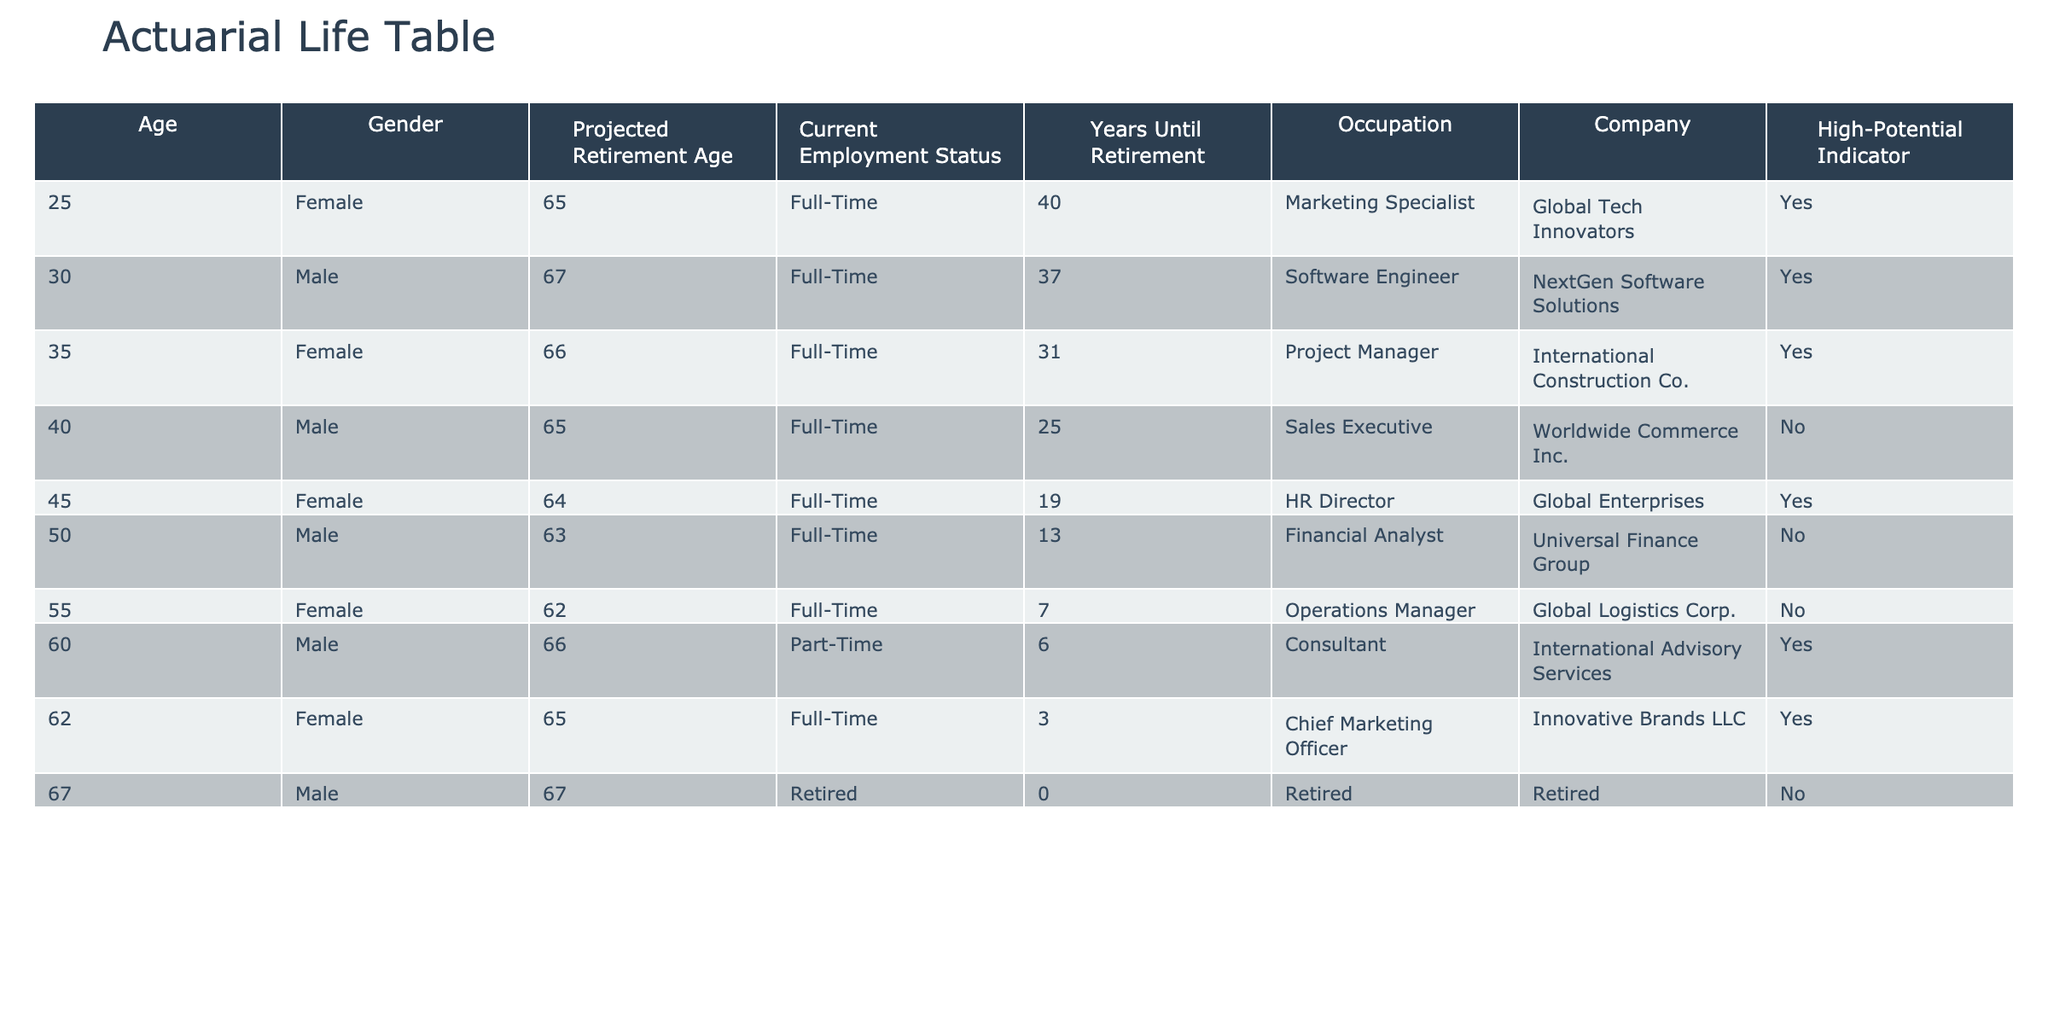What is the projected retirement age for the female Marketing Specialist? The table indicates that the female Marketing Specialist has a projected retirement age of 65.
Answer: 65 How many years until retirement does the male Software Engineer have? According to the table, the male Software Engineer has 37 years until retirement.
Answer: 37 How many employees in the table are indicated as high-potential? The table shows a total of 5 high-potential employees when counting the 'High-Potential Indicator' column that has "Yes".
Answer: 5 What is the average projected retirement age for all employees? To find the average, we first sum the projected retirement ages: (65 + 67 + 66 + 65 + 64 + 63 + 62 + 66 + 65 + 67) = 655. There are 10 employees, so the average is 655/10 = 65.5.
Answer: 65.5 Is the HR Director a high-potential employee? Referring to the 'High-Potential Indicator' in the table, it shows "Yes" for the HR Director, which means she is indeed considered a high-potential employee.
Answer: Yes What is the retirement age for the male financial analyst? Looking at the table, the male Financial Analyst is projected to retire at the age of 63.
Answer: 63 How many years until retirement is the female Chief Marketing Officer? The table indicates that the female Chief Marketing Officer has 3 years until retirement.
Answer: 3 Which occupation has the highest age difference from the projected retirement age among employees? To find the occupational age differences, we need to calculate the difference between the projected retirement ages and current ages for each occupation. The maximum age difference is for the female Operations Manager, who is currently 55 and has a projected retirement age of 62, which gives a difference of 7 years.
Answer: 7 Are there any part-time employees projected to retire before age 65? The data indicates that the only part-time employee, a male consultant, has a projected retirement age of 66, which means there are no part-time employees projected to retire before age 65.
Answer: No 